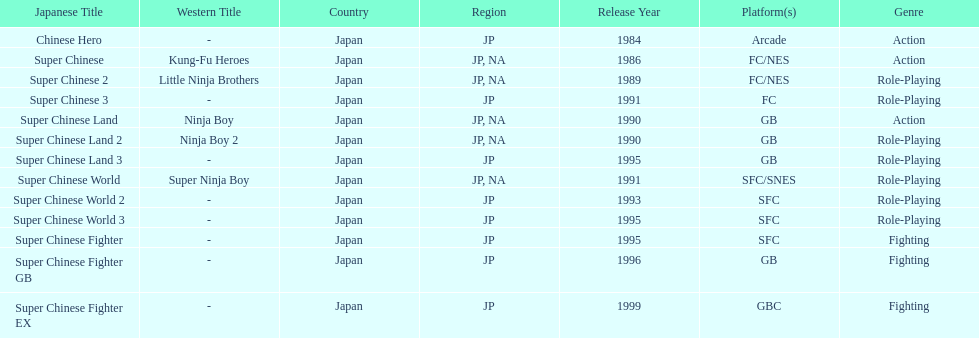Which platforms had the most titles released? GB. 